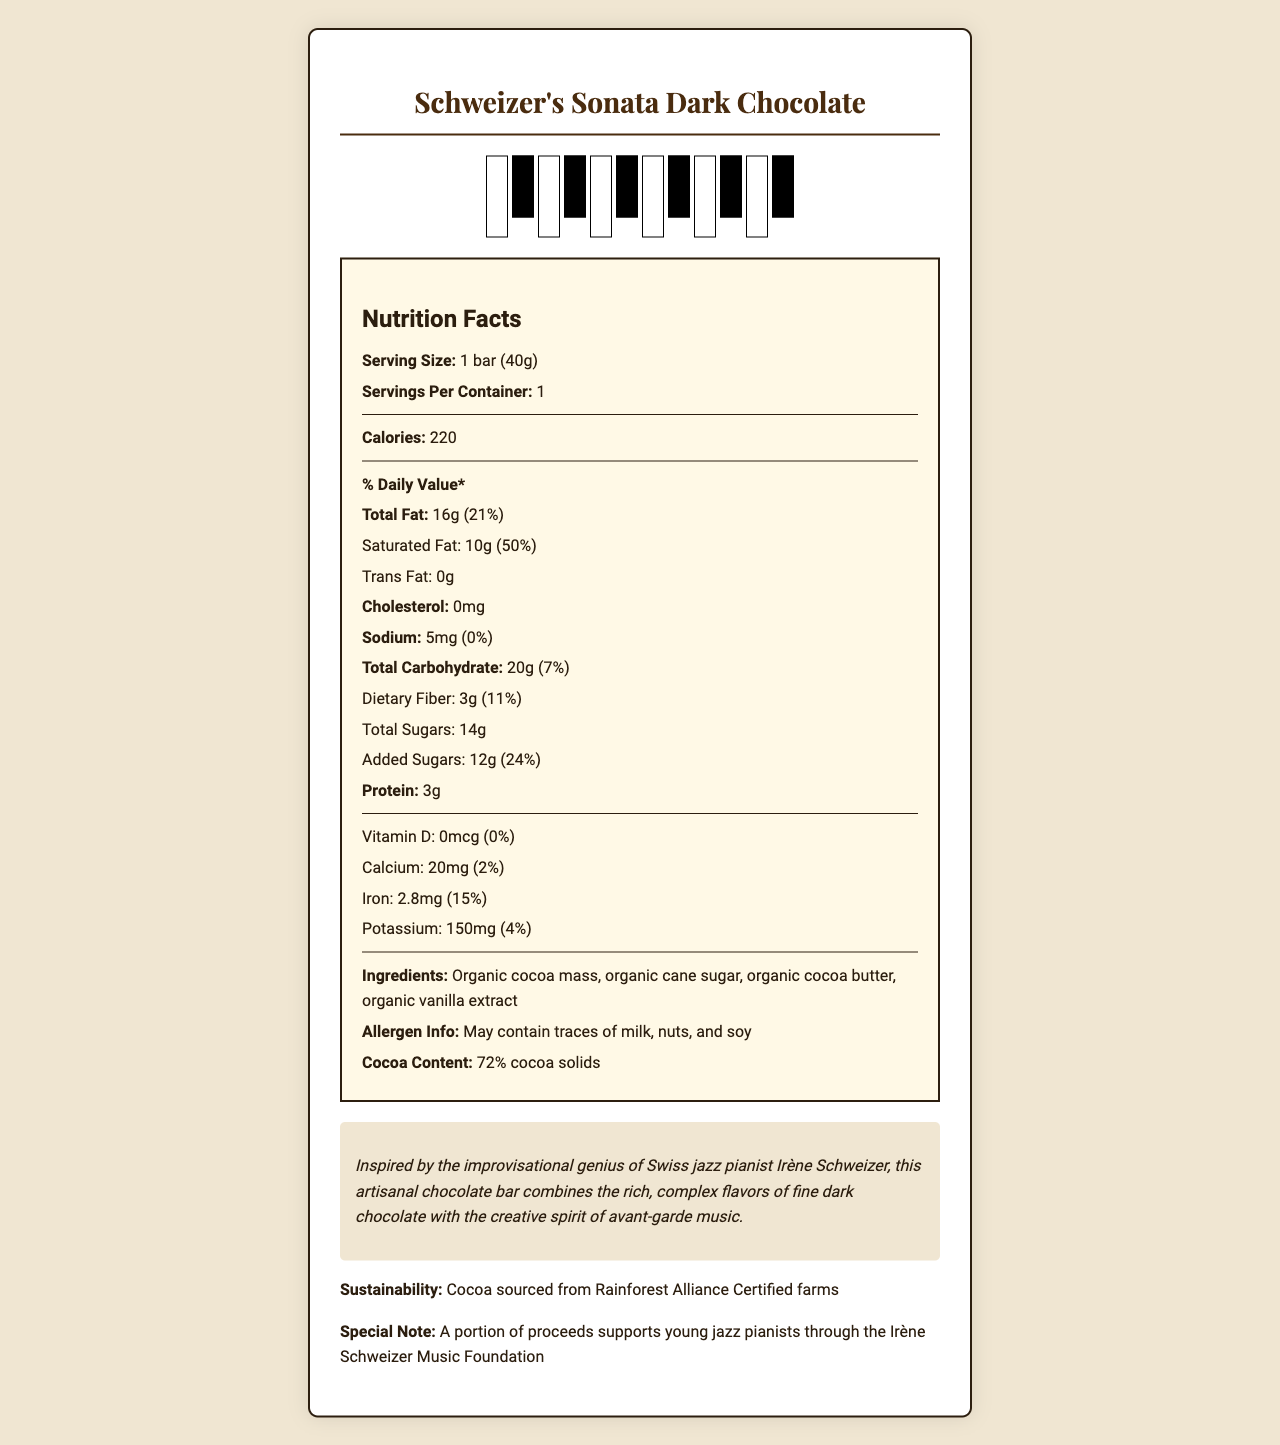what is the serving size of this chocolate bar? The serving size is listed as "1 bar (40g)" in the Nutrition Facts label.
Answer: 1 bar (40g) how many calories does one serving of this chocolate bar contain? Under the "Calories" section, it states that one serving contains 220 calories.
Answer: 220 calories what is the total fat content in this chocolate bar, and what percentage of the daily value does it represent? The document states, "Total Fat: 16g (21%)."
Answer: 16g, 21% how much of the total carbohydrate content in this chocolate bar is dietary fiber? The Dietary Fiber is listed separately under Total Carbohydrate as "3g."
Answer: 3g where is the cocoa for this chocolate sourced from? The document mentions under Sustainability, "Cocoa sourced from Rainforest Alliance Certified farms."
Answer: Rainforest Alliance Certified farms when consuming this chocolate bar, how much protein will you intake? The protein content is listed as "3g."
Answer: 3g what is the saturated fat content of this chocolate bar in grams and its percentage of daily value? Saturated Fat is listed as "10g (50%)."
Answer: 10g, 50% how much added sugars does this chocolate bar contain? Added Sugars are listed as "12g."
Answer: 12g including potential allergens, summarize the allergen information provided. Under Allergen Info, it states "May contain traces of milk, nuts, and soy."
Answer: May contain traces of milk, nuts, and soy how many servings are in one container of this chocolate bar? The document specifies that there are "1 servings per container."
Answer: 1 which of the following ingredients is not listed in the ingredients section? A. Organic vanilla extract B. Organic cocoa butter C. Organic milk powder D. Organic cane sugar The listed ingredients are Organic cocoa mass, organic cane sugar, organic cocoa butter, and organic vanilla extract. Organic milk powder is not listed.
Answer: C. Organic milk powder what is the percentage of daily value for calcium provided by this chocolate bar? A. 1% B. 2% C. 10% D. 15% The document lists Calcium as "20mg (2%)."
Answer: B. 2% does the wrapper of this chocolate bar feature a QR code linking to Irène Schweizer's jazz performance? The packaging features mention a "QR code linking to Irène Schweizer's jazz performance."
Answer: Yes is there information available about the amount of cholesterol in this chocolate bar? The Cholesterol content is listed as "0mg."
Answer: Yes how does the brand story associate the product with Irène Schweizer? The brand story directly connects the chocolate with Irène Schweizer’s spirit and genius.
Answer: The brand story says, "Inspired by the improvisational genius of Swiss jazz pianist Irène Schweizer, this artisanal chocolate bar combines the rich, complex flavors of fine dark chocolate with the creative spirit of avant-garde music." describe the main idea of the document. The document provides a comprehensive overview of the chocolate bar's nutritional content, ingredient list, allergen warnings, and brand story, highlighting its unique features that pay tribute to Irène Schweizer.
Answer: The document describes the nutritional content and ingredients of Schweizer's Sonata Dark Chocolate, a gourmet chocolate bar inspired by Swiss jazz pianist Irène Schweizer. It includes detailed nutritional values, ingredients, allergen information, sustainability practices, and unique packaging features. what coding framework is used to generate this document? The document itself visually does not provide any information about the coding frameworks used.
Answer: Not enough information how much potassium is in one serving, and what percentage of the daily value does it represent? The Potassium content is listed as "150mg (4%)."
Answer: 150mg, 4% 